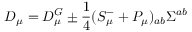<formula> <loc_0><loc_0><loc_500><loc_500>D _ { \mu } = D _ { \mu } ^ { G } \pm \frac { 1 } { 4 } ( S _ { \mu } ^ { - } + P _ { \mu } ) _ { a b } \Sigma ^ { a b }</formula> 